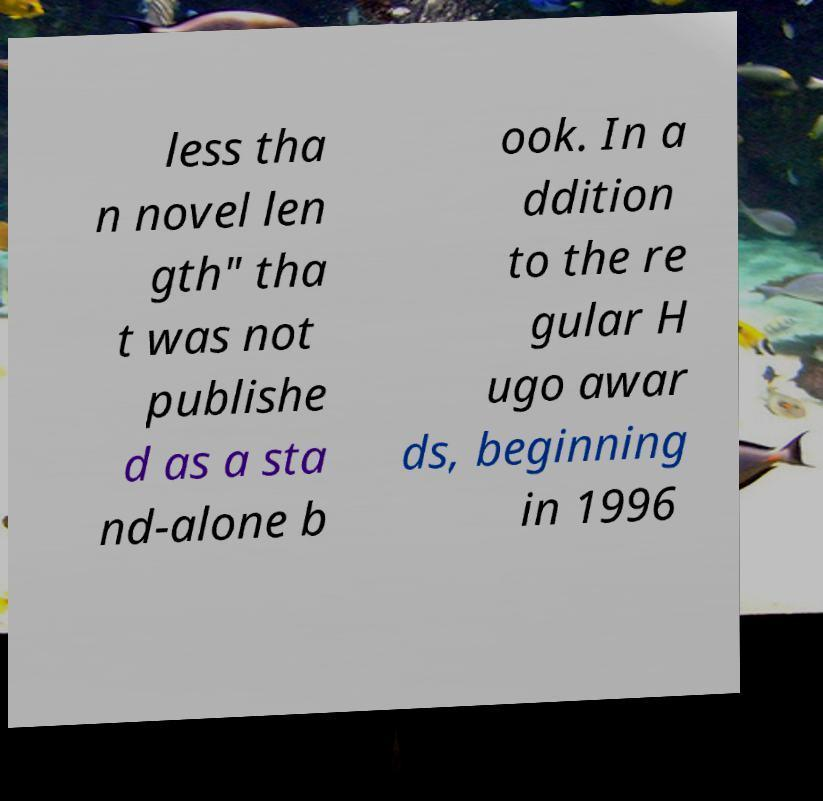Can you accurately transcribe the text from the provided image for me? less tha n novel len gth" tha t was not publishe d as a sta nd-alone b ook. In a ddition to the re gular H ugo awar ds, beginning in 1996 